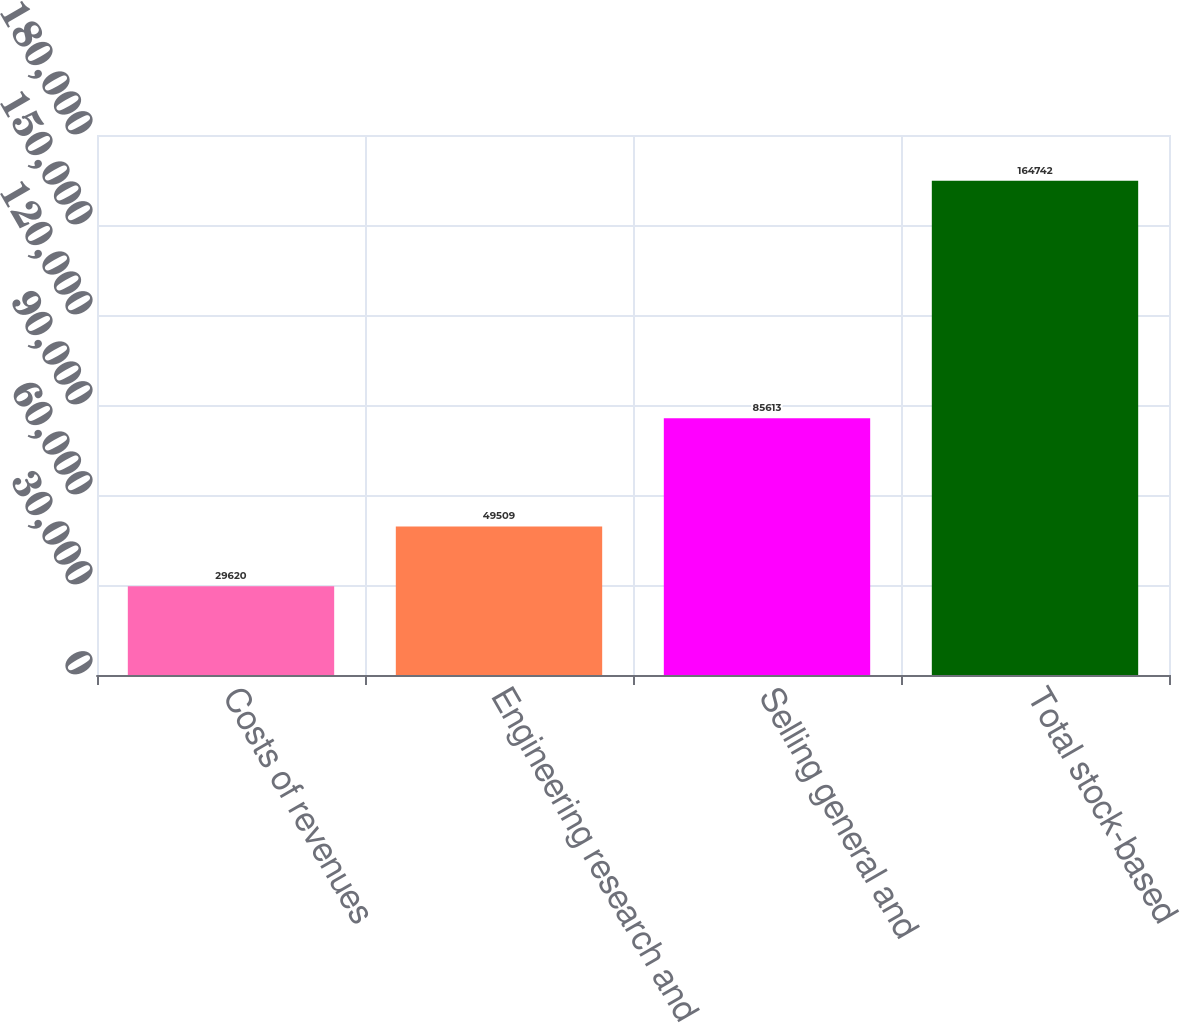Convert chart. <chart><loc_0><loc_0><loc_500><loc_500><bar_chart><fcel>Costs of revenues<fcel>Engineering research and<fcel>Selling general and<fcel>Total stock-based<nl><fcel>29620<fcel>49509<fcel>85613<fcel>164742<nl></chart> 